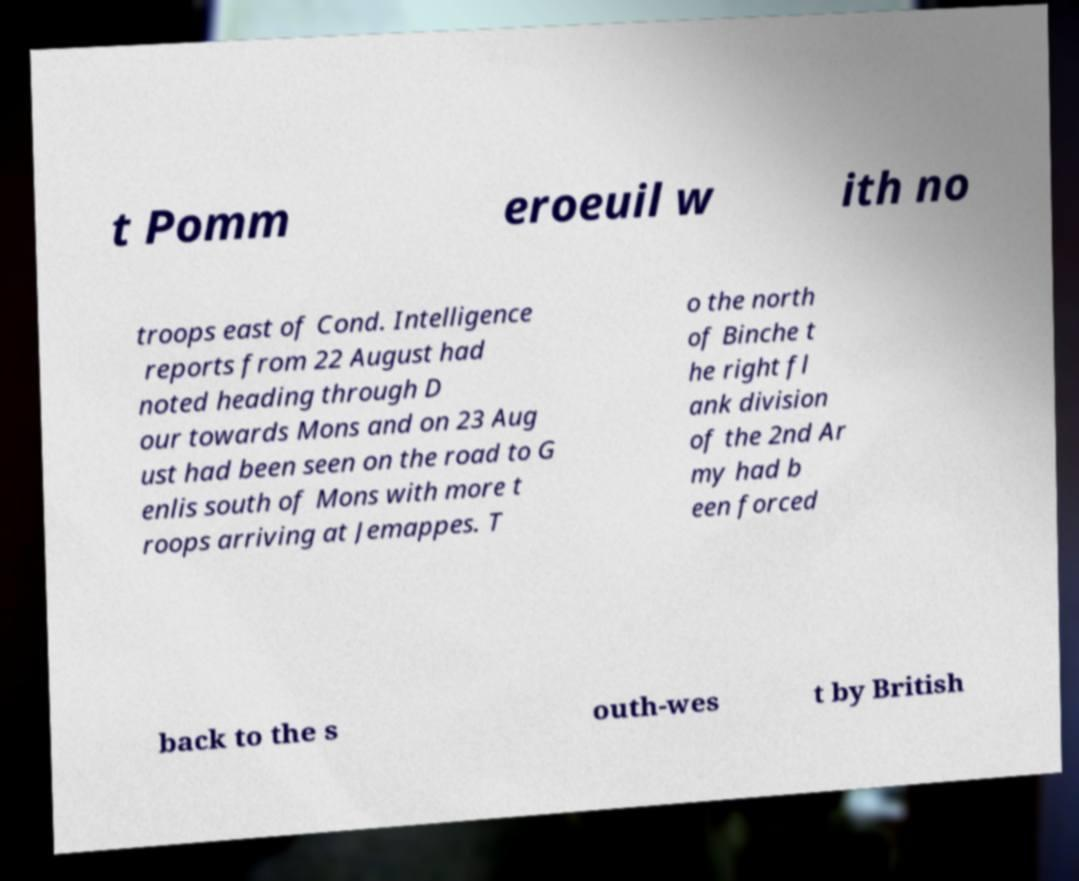Can you accurately transcribe the text from the provided image for me? t Pomm eroeuil w ith no troops east of Cond. Intelligence reports from 22 August had noted heading through D our towards Mons and on 23 Aug ust had been seen on the road to G enlis south of Mons with more t roops arriving at Jemappes. T o the north of Binche t he right fl ank division of the 2nd Ar my had b een forced back to the s outh-wes t by British 